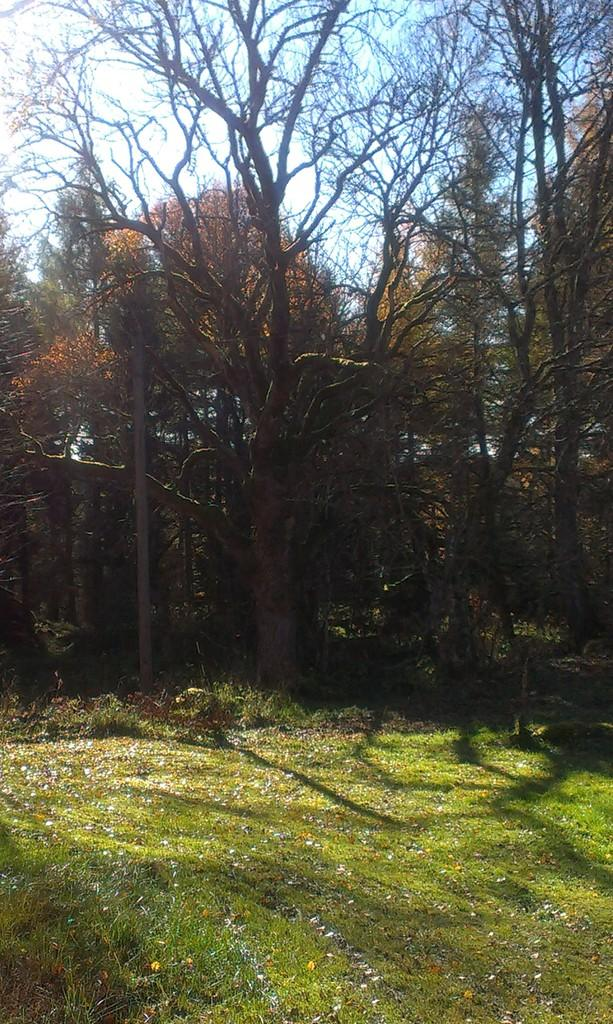What type of vegetation is on the ground in the image? There is grass on the ground in the image. What can be seen in the background of the image? There are trees and the sky visible in the background of the image. What type of creature can be seen playing basketball in the alley in the image? There is no creature playing basketball in the alley in the image; it does not contain any basketball or alley elements. 